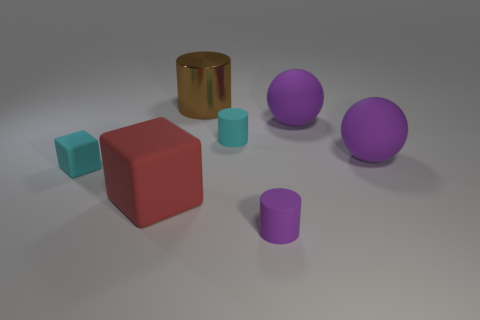There is a matte object in front of the big matte cube; what size is it?
Offer a terse response. Small. What is the cube on the left side of the big red block made of?
Keep it short and to the point. Rubber. How many cyan objects are either balls or small rubber things?
Your answer should be very brief. 2. Does the tiny purple cylinder have the same material as the large brown cylinder on the right side of the large block?
Keep it short and to the point. No. Is the number of purple rubber cylinders that are right of the cyan cube the same as the number of matte things that are in front of the tiny purple cylinder?
Your response must be concise. No. Is the size of the purple matte cylinder the same as the object that is left of the large red rubber block?
Make the answer very short. Yes. Are there more big purple rubber things that are behind the big brown shiny thing than tiny cyan cylinders?
Your response must be concise. No. What number of purple matte balls have the same size as the brown thing?
Your answer should be compact. 2. There is a purple thing behind the cyan matte cylinder; does it have the same size as the cyan matte object that is to the right of the large brown metallic object?
Offer a very short reply. No. Are there more small cyan cubes that are right of the red rubber block than rubber objects that are on the right side of the cyan cube?
Offer a terse response. No. 